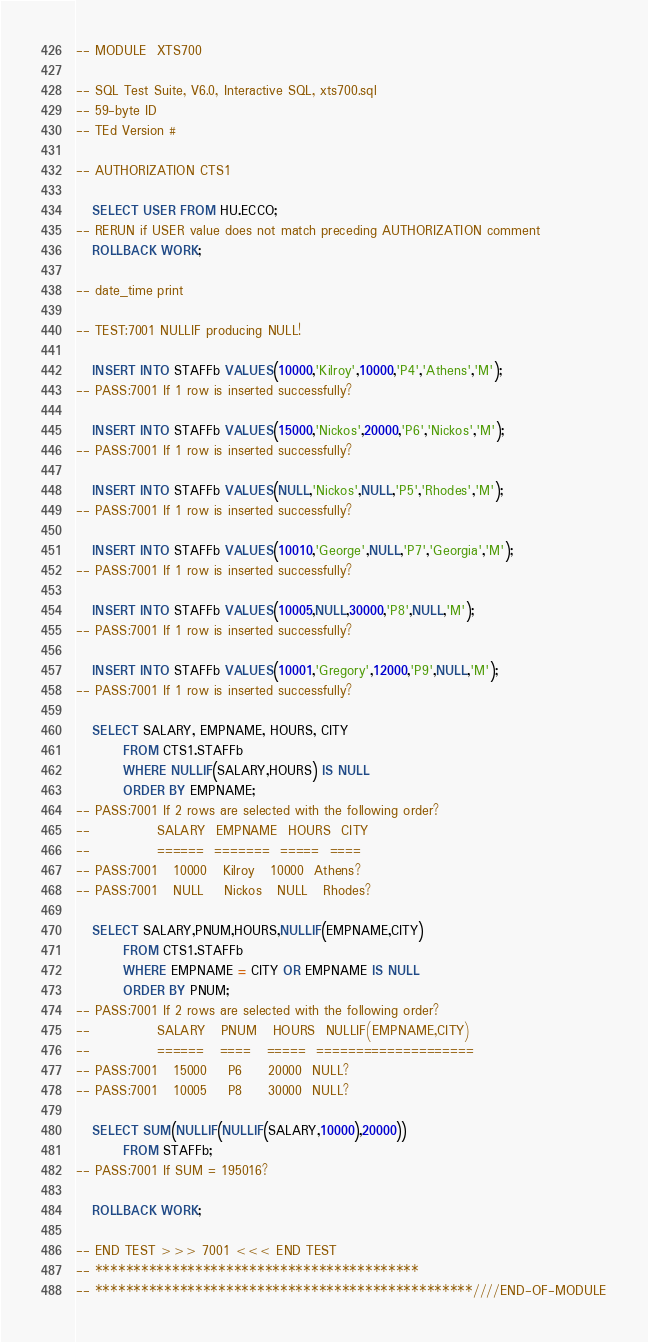Convert code to text. <code><loc_0><loc_0><loc_500><loc_500><_SQL_>-- MODULE  XTS700  

-- SQL Test Suite, V6.0, Interactive SQL, xts700.sql
-- 59-byte ID
-- TEd Version #

-- AUTHORIZATION CTS1              

   SELECT USER FROM HU.ECCO;
-- RERUN if USER value does not match preceding AUTHORIZATION comment
   ROLLBACK WORK;

-- date_time print

-- TEST:7001 NULLIF producing NULL!

   INSERT INTO STAFFb VALUES(10000,'Kilroy',10000,'P4','Athens','M');
-- PASS:7001 If 1 row is inserted successfully?

   INSERT INTO STAFFb VALUES(15000,'Nickos',20000,'P6','Nickos','M');
-- PASS:7001 If 1 row is inserted successfully?

   INSERT INTO STAFFb VALUES(NULL,'Nickos',NULL,'P5','Rhodes','M');
-- PASS:7001 If 1 row is inserted successfully?

   INSERT INTO STAFFb VALUES(10010,'George',NULL,'P7','Georgia','M');
-- PASS:7001 If 1 row is inserted successfully?

   INSERT INTO STAFFb VALUES(10005,NULL,30000,'P8',NULL,'M');
-- PASS:7001 If 1 row is inserted successfully?

   INSERT INTO STAFFb VALUES(10001,'Gregory',12000,'P9',NULL,'M');
-- PASS:7001 If 1 row is inserted successfully?

   SELECT SALARY, EMPNAME, HOURS, CITY
         FROM CTS1.STAFFb
         WHERE NULLIF(SALARY,HOURS) IS NULL
         ORDER BY EMPNAME;
-- PASS:7001 If 2 rows are selected with the following order?
--             SALARY  EMPNAME  HOURS  CITY
--             ======  =======  =====  ====
-- PASS:7001   10000   Kilroy   10000  Athens?
-- PASS:7001   NULL    Nickos   NULL   Rhodes?

   SELECT SALARY,PNUM,HOURS,NULLIF(EMPNAME,CITY)
         FROM CTS1.STAFFb
         WHERE EMPNAME = CITY OR EMPNAME IS NULL 
         ORDER BY PNUM;
-- PASS:7001 If 2 rows are selected with the following order?
--             SALARY   PNUM   HOURS  NULLIF(EMPNAME,CITY)
--             ======   ====   =====  ==================== 
-- PASS:7001   15000    P6     20000  NULL?
-- PASS:7001   10005    P8     30000  NULL?

   SELECT SUM(NULLIF(NULLIF(SALARY,10000),20000))
         FROM STAFFb;
-- PASS:7001 If SUM = 195016? 

   ROLLBACK WORK;

-- END TEST >>> 7001 <<< END TEST
-- ******************************************
-- *************************************************////END-OF-MODULE
</code> 